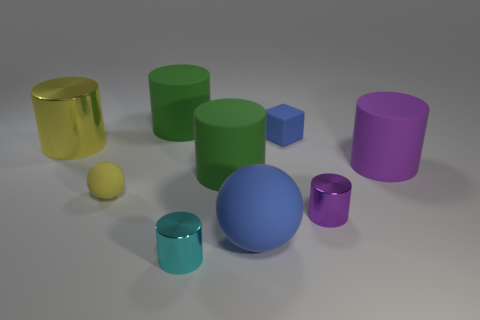What material is the other purple thing that is the same shape as the big purple object?
Your answer should be compact. Metal. Are there any small yellow balls behind the shiny object on the right side of the thing that is in front of the large blue rubber sphere?
Your answer should be compact. Yes. There is a tiny blue rubber thing; does it have the same shape as the metallic object on the right side of the cyan object?
Ensure brevity in your answer.  No. Is there any other thing of the same color as the tiny sphere?
Offer a terse response. Yes. Is the color of the large rubber thing that is right of the tiny purple metallic thing the same as the small metal object right of the big blue sphere?
Your answer should be very brief. Yes. Is there a brown shiny cylinder?
Provide a short and direct response. No. Are there any blue blocks that have the same material as the large purple cylinder?
Provide a succinct answer. Yes. What color is the cube?
Offer a very short reply. Blue. The rubber object that is the same color as the large ball is what shape?
Your answer should be very brief. Cube. There is a metallic thing that is the same size as the blue rubber sphere; what is its color?
Offer a terse response. Yellow. 